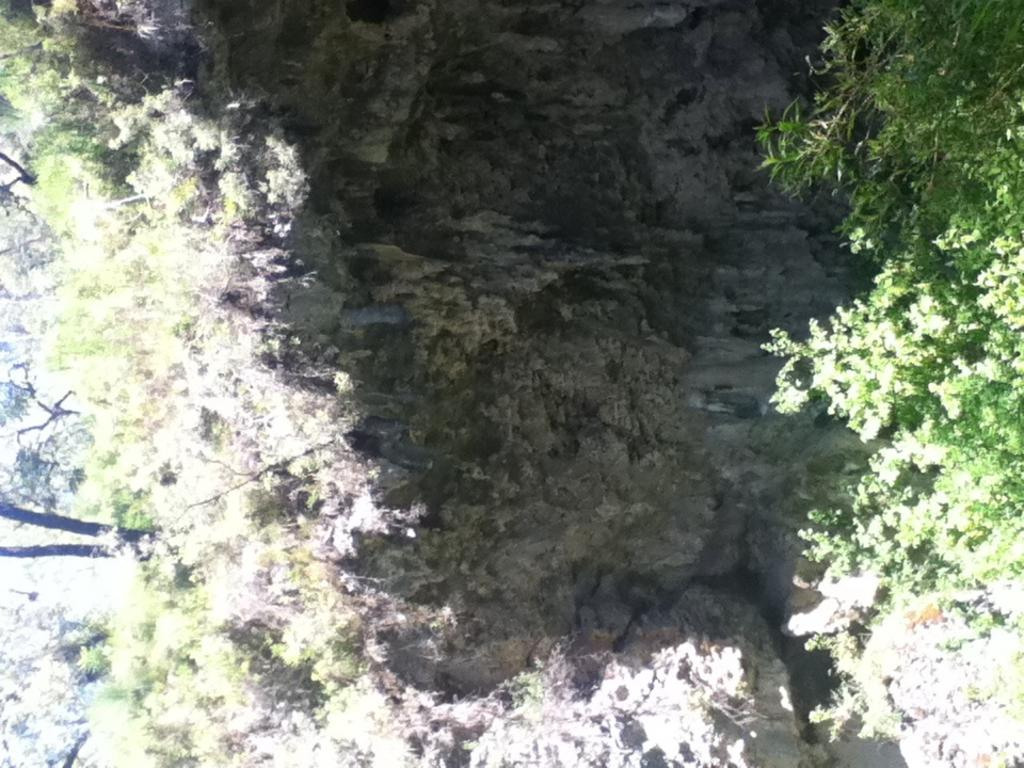What type of vegetation is present in the image? There is a group of trees in the image. Can you describe the trees in the image? The provided facts do not give specific details about the trees, so we cannot describe them further. What might be the purpose of the trees in the image? The purpose of the trees in the image is not explicitly stated, but they could be providing shade, serving as a natural barrier, or simply adding to the landscape. What type of store can be seen in the image? There is no store present in the image; it only features a group of trees. 